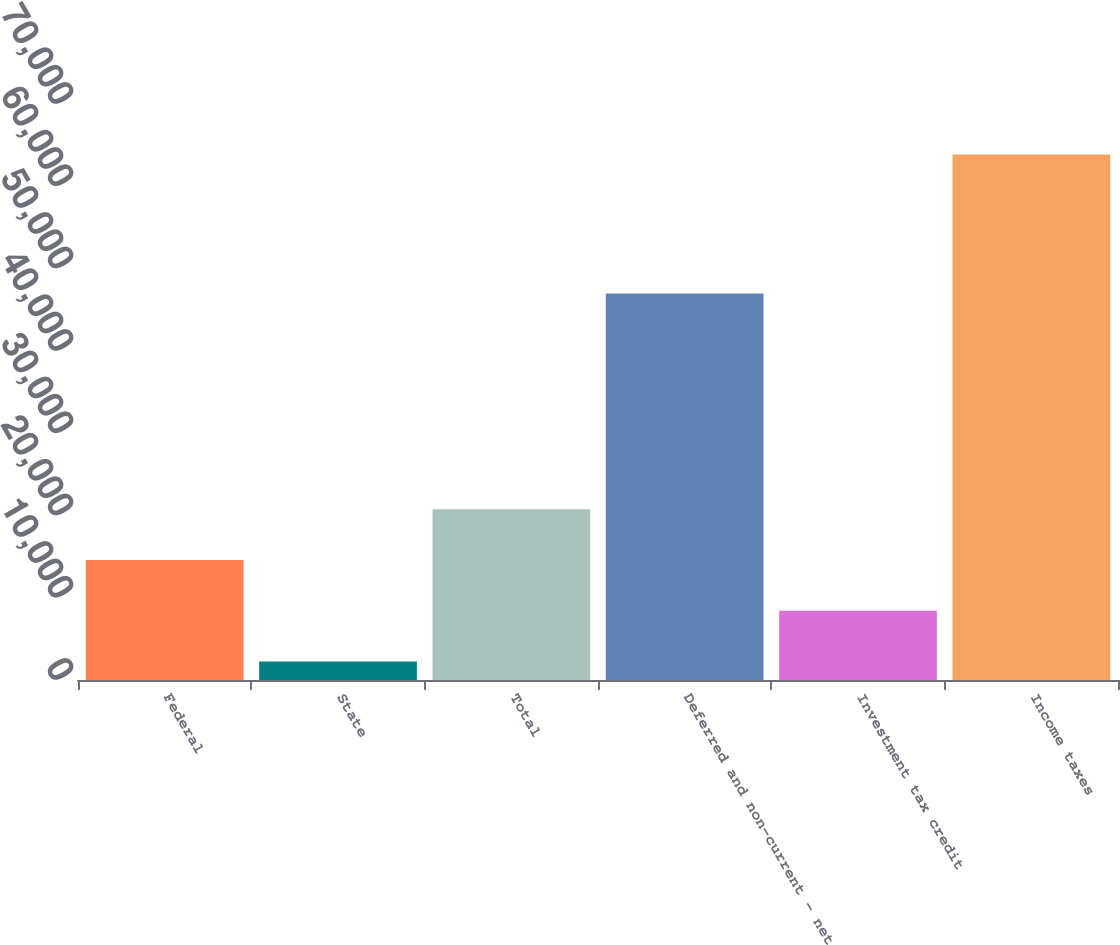Convert chart. <chart><loc_0><loc_0><loc_500><loc_500><bar_chart><fcel>Federal<fcel>State<fcel>Total<fcel>Deferred and non-current - net<fcel>Investment tax credit<fcel>Income taxes<nl><fcel>14576.4<fcel>2257<fcel>20736.1<fcel>46984<fcel>8416.7<fcel>63854<nl></chart> 